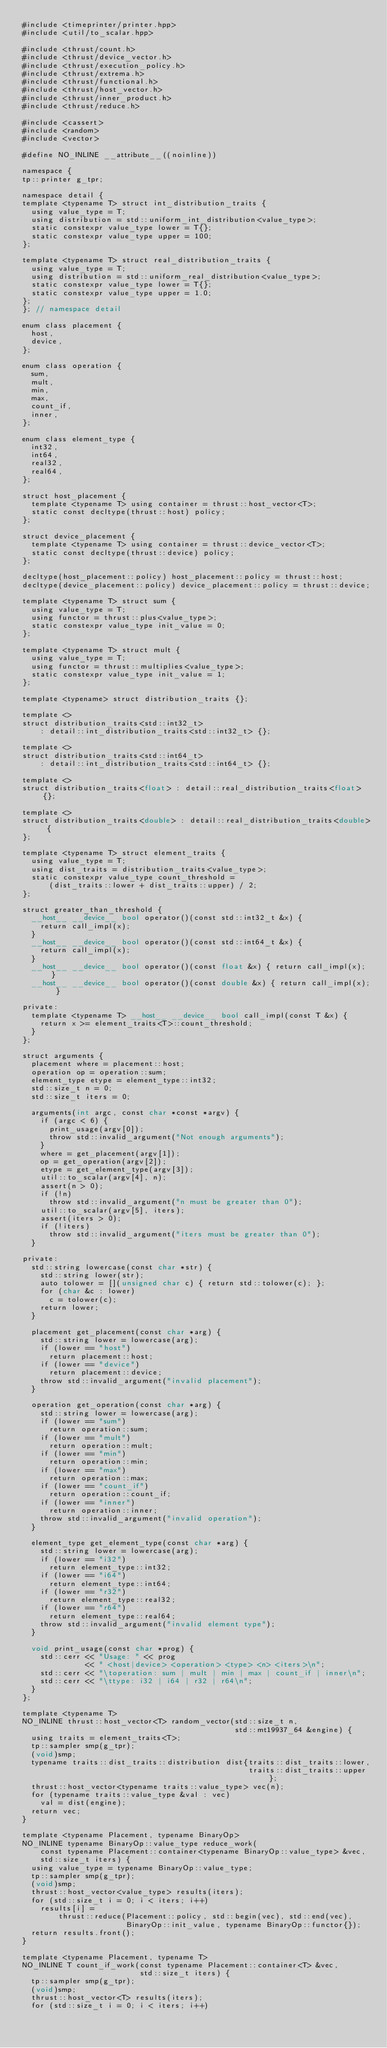Convert code to text. <code><loc_0><loc_0><loc_500><loc_500><_Cuda_>#include <timeprinter/printer.hpp>
#include <util/to_scalar.hpp>

#include <thrust/count.h>
#include <thrust/device_vector.h>
#include <thrust/execution_policy.h>
#include <thrust/extrema.h>
#include <thrust/functional.h>
#include <thrust/host_vector.h>
#include <thrust/inner_product.h>
#include <thrust/reduce.h>

#include <cassert>
#include <random>
#include <vector>

#define NO_INLINE __attribute__((noinline))

namespace {
tp::printer g_tpr;

namespace detail {
template <typename T> struct int_distribution_traits {
  using value_type = T;
  using distribution = std::uniform_int_distribution<value_type>;
  static constexpr value_type lower = T{};
  static constexpr value_type upper = 100;
};

template <typename T> struct real_distribution_traits {
  using value_type = T;
  using distribution = std::uniform_real_distribution<value_type>;
  static constexpr value_type lower = T{};
  static constexpr value_type upper = 1.0;
};
}; // namespace detail

enum class placement {
  host,
  device,
};

enum class operation {
  sum,
  mult,
  min,
  max,
  count_if,
  inner,
};

enum class element_type {
  int32,
  int64,
  real32,
  real64,
};

struct host_placement {
  template <typename T> using container = thrust::host_vector<T>;
  static const decltype(thrust::host) policy;
};

struct device_placement {
  template <typename T> using container = thrust::device_vector<T>;
  static const decltype(thrust::device) policy;
};

decltype(host_placement::policy) host_placement::policy = thrust::host;
decltype(device_placement::policy) device_placement::policy = thrust::device;

template <typename T> struct sum {
  using value_type = T;
  using functor = thrust::plus<value_type>;
  static constexpr value_type init_value = 0;
};

template <typename T> struct mult {
  using value_type = T;
  using functor = thrust::multiplies<value_type>;
  static constexpr value_type init_value = 1;
};

template <typename> struct distribution_traits {};

template <>
struct distribution_traits<std::int32_t>
    : detail::int_distribution_traits<std::int32_t> {};

template <>
struct distribution_traits<std::int64_t>
    : detail::int_distribution_traits<std::int64_t> {};

template <>
struct distribution_traits<float> : detail::real_distribution_traits<float> {};

template <>
struct distribution_traits<double> : detail::real_distribution_traits<double> {
};

template <typename T> struct element_traits {
  using value_type = T;
  using dist_traits = distribution_traits<value_type>;
  static constexpr value_type count_threshold =
      (dist_traits::lower + dist_traits::upper) / 2;
};

struct greater_than_threshold {
  __host__ __device__ bool operator()(const std::int32_t &x) {
    return call_impl(x);
  }
  __host__ __device__ bool operator()(const std::int64_t &x) {
    return call_impl(x);
  }
  __host__ __device__ bool operator()(const float &x) { return call_impl(x); }
  __host__ __device__ bool operator()(const double &x) { return call_impl(x); }

private:
  template <typename T> __host__ __device__ bool call_impl(const T &x) {
    return x >= element_traits<T>::count_threshold;
  }
};

struct arguments {
  placement where = placement::host;
  operation op = operation::sum;
  element_type etype = element_type::int32;
  std::size_t n = 0;
  std::size_t iters = 0;

  arguments(int argc, const char *const *argv) {
    if (argc < 6) {
      print_usage(argv[0]);
      throw std::invalid_argument("Not enough arguments");
    }
    where = get_placement(argv[1]);
    op = get_operation(argv[2]);
    etype = get_element_type(argv[3]);
    util::to_scalar(argv[4], n);
    assert(n > 0);
    if (!n)
      throw std::invalid_argument("n must be greater than 0");
    util::to_scalar(argv[5], iters);
    assert(iters > 0);
    if (!iters)
      throw std::invalid_argument("iters must be greater than 0");
  }

private:
  std::string lowercase(const char *str) {
    std::string lower(str);
    auto tolower = [](unsigned char c) { return std::tolower(c); };
    for (char &c : lower)
      c = tolower(c);
    return lower;
  }

  placement get_placement(const char *arg) {
    std::string lower = lowercase(arg);
    if (lower == "host")
      return placement::host;
    if (lower == "device")
      return placement::device;
    throw std::invalid_argument("invalid placement");
  }

  operation get_operation(const char *arg) {
    std::string lower = lowercase(arg);
    if (lower == "sum")
      return operation::sum;
    if (lower == "mult")
      return operation::mult;
    if (lower == "min")
      return operation::min;
    if (lower == "max")
      return operation::max;
    if (lower == "count_if")
      return operation::count_if;
    if (lower == "inner")
      return operation::inner;
    throw std::invalid_argument("invalid operation");
  }

  element_type get_element_type(const char *arg) {
    std::string lower = lowercase(arg);
    if (lower == "i32")
      return element_type::int32;
    if (lower == "i64")
      return element_type::int64;
    if (lower == "r32")
      return element_type::real32;
    if (lower == "r64")
      return element_type::real64;
    throw std::invalid_argument("invalid element type");
  }

  void print_usage(const char *prog) {
    std::cerr << "Usage: " << prog
              << " <host|device> <operation> <type> <n> <iters>\n";
    std::cerr << "\toperation: sum | mult | min | max | count_if | inner\n";
    std::cerr << "\ttype: i32 | i64 | r32 | r64\n";
  }
};

template <typename T>
NO_INLINE thrust::host_vector<T> random_vector(std::size_t n,
                                               std::mt19937_64 &engine) {
  using traits = element_traits<T>;
  tp::sampler smp(g_tpr);
  (void)smp;
  typename traits::dist_traits::distribution dist{traits::dist_traits::lower,
                                                  traits::dist_traits::upper};
  thrust::host_vector<typename traits::value_type> vec(n);
  for (typename traits::value_type &val : vec)
    val = dist(engine);
  return vec;
}

template <typename Placement, typename BinaryOp>
NO_INLINE typename BinaryOp::value_type reduce_work(
    const typename Placement::container<typename BinaryOp::value_type> &vec,
    std::size_t iters) {
  using value_type = typename BinaryOp::value_type;
  tp::sampler smp(g_tpr);
  (void)smp;
  thrust::host_vector<value_type> results(iters);
  for (std::size_t i = 0; i < iters; i++)
    results[i] =
        thrust::reduce(Placement::policy, std::begin(vec), std::end(vec),
                       BinaryOp::init_value, typename BinaryOp::functor{});
  return results.front();
}

template <typename Placement, typename T>
NO_INLINE T count_if_work(const typename Placement::container<T> &vec,
                          std::size_t iters) {
  tp::sampler smp(g_tpr);
  (void)smp;
  thrust::host_vector<T> results(iters);
  for (std::size_t i = 0; i < iters; i++)</code> 